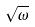<formula> <loc_0><loc_0><loc_500><loc_500>\sqrt { \omega }</formula> 